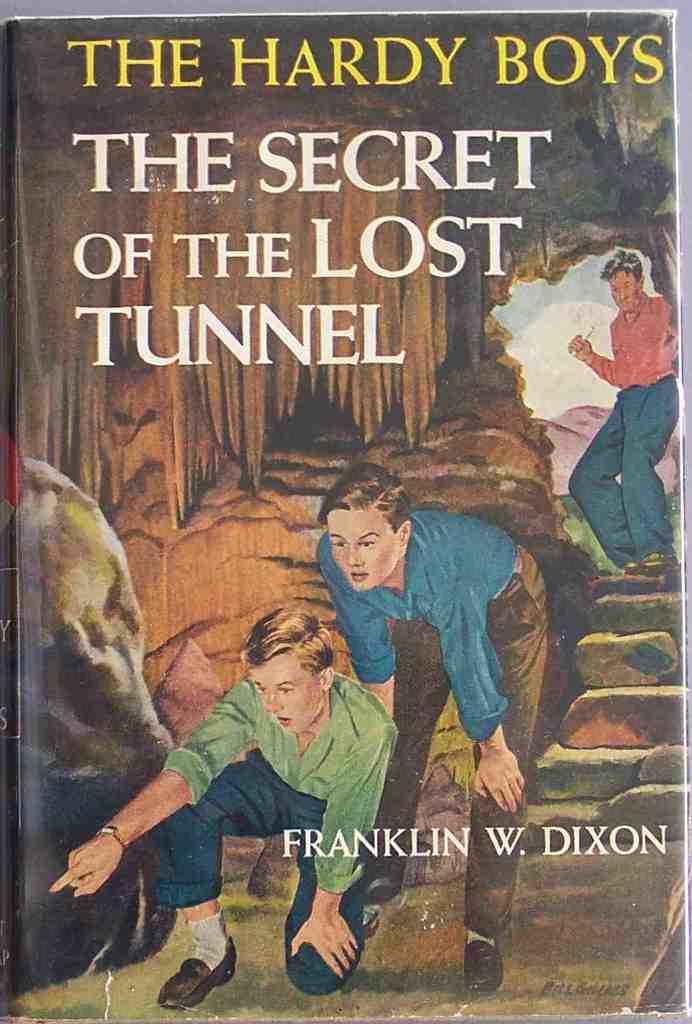What is the title of the book?
Your response must be concise. The secret of the lost tunnel. Who wrote this book?
Your answer should be very brief. Franklin w. dixon. 